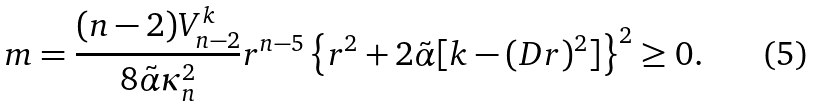<formula> <loc_0><loc_0><loc_500><loc_500>m = \frac { ( n - 2 ) V _ { n - 2 } ^ { k } } { 8 { \tilde { \alpha } } \kappa _ { n } ^ { 2 } } r ^ { n - 5 } \left \{ r ^ { 2 } + 2 { \tilde { \alpha } } [ k - ( D r ) ^ { 2 } ] \right \} ^ { 2 } \geq 0 .</formula> 